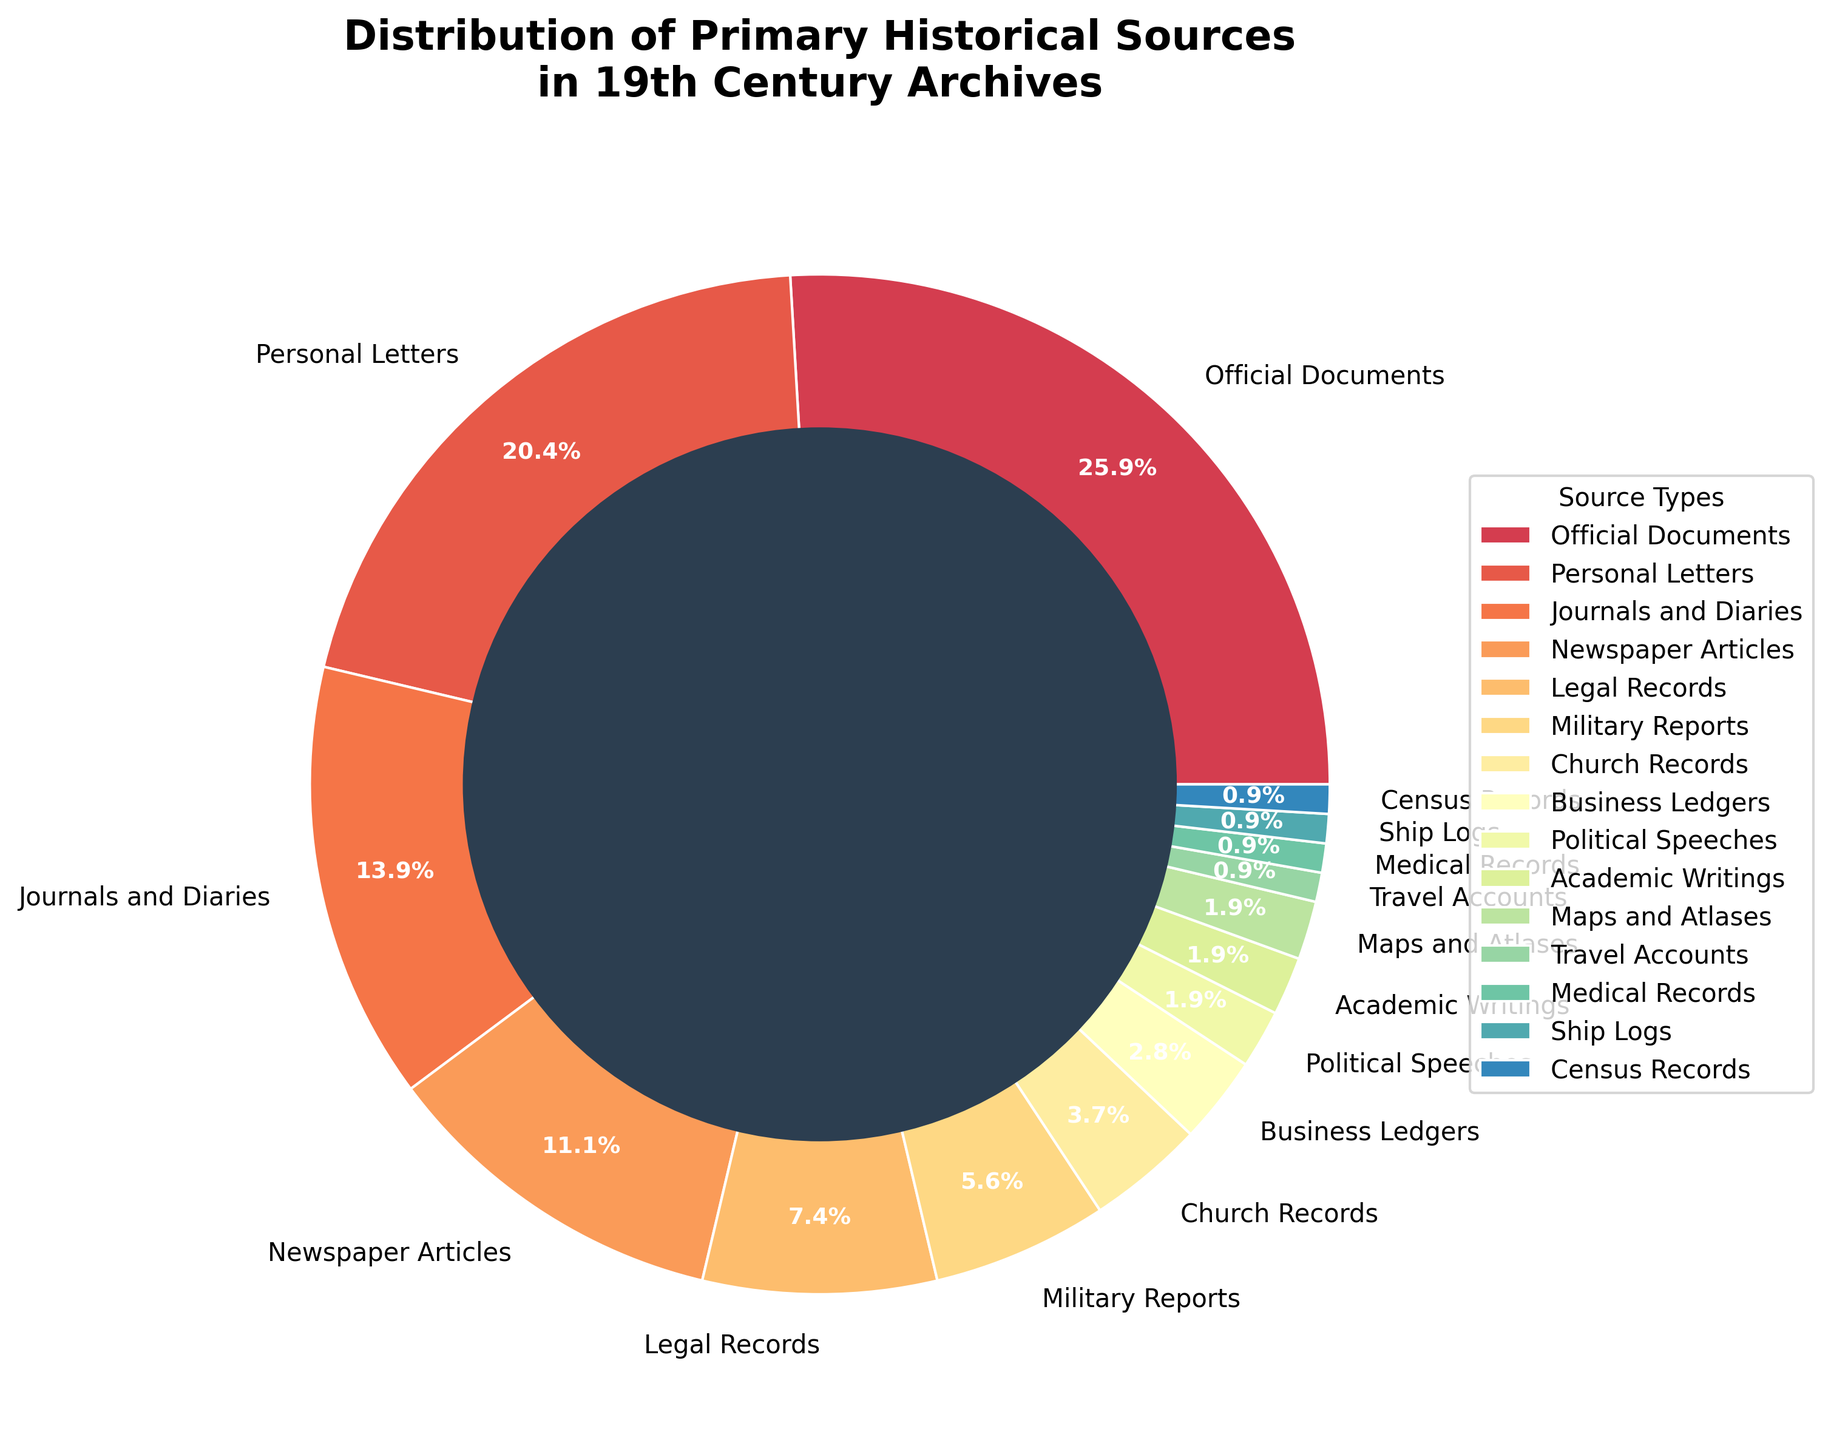What is the most common type of primary historical source in 19th century archives? The pie chart indicates that Official Documents represent the largest section with 28%.
Answer: Official Documents Which type of source is more common: Personal Letters or Journals and Diaries? Personal Letters occupy 22% of the pie chart, while Journals and Diaries make up 15%. Therefore, Personal Letters are more common.
Answer: Personal Letters How do the percentages of Legal Records and Newspaper Articles compare? Legal Records account for 8% of the distribution, whereas Newspaper Articles account for 12%. Therefore, Newspaper Articles are more common than Legal Records.
Answer: Newspaper Articles What is the combined percentage of Political Speeches and Academic Writings? Both Political Speeches and Academic Writings each occupy 2% of the pie chart. So, combined, they make up 4%.
Answer: 4% By how much does the percentage of Church Records exceed the percentage of Business Ledgers? Church Records comprise 4% of the distribution, whereas Business Ledgers make up 3%. The difference is 4% - 3% = 1%.
Answer: 1% What is the total percentage of sources related to travel, including Maps and Atlases, Ship Logs, and Travel Accounts? Maps and Atlases account for 2%, Ship Logs account for 1%, and Travel Accounts account for 1%. The combined percentage is 2% + 1% + 1% = 4%.
Answer: 4% Which sources share the same percentage in the distribution? Comparing the percentages, Maps and Atlases, Political Speeches, and Academic Writings all share the same percentage, at 2% each.
Answer: Maps and Atlases, Political Speeches, Academic Writings How many source types have percentages below 5%? The pie chart shows that Church Records, Business Ledgers, Maps and Atlases, Academic Writings, Political Speeches, Census Records, Ship Logs, Medical Records, and Travel Accounts each have percentages below 5%. There are 10 source types.
Answer: 10 What is the percentage difference between Military Reports and Census Records? Military Reports account for 6% and Census Records account for 1%. The difference in their percentages is 6% - 1% = 5%.
Answer: 5% What is the average percentage of the four least common source types? The four least common source types are Medical Records (1%), Travel Accounts (1%), Ship Logs (1%), and Census Records (1%). Their average is (1% + 1% + 1% + 1%) / 4 = 1%.
Answer: 1% 